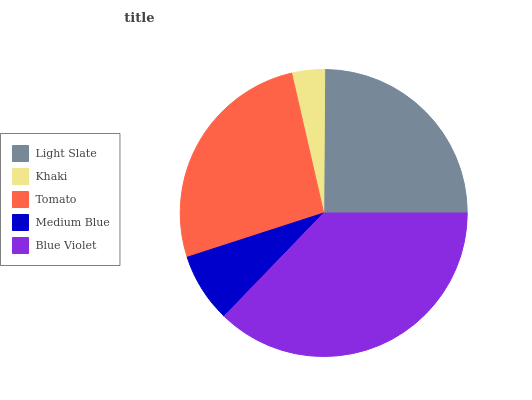Is Khaki the minimum?
Answer yes or no. Yes. Is Blue Violet the maximum?
Answer yes or no. Yes. Is Tomato the minimum?
Answer yes or no. No. Is Tomato the maximum?
Answer yes or no. No. Is Tomato greater than Khaki?
Answer yes or no. Yes. Is Khaki less than Tomato?
Answer yes or no. Yes. Is Khaki greater than Tomato?
Answer yes or no. No. Is Tomato less than Khaki?
Answer yes or no. No. Is Light Slate the high median?
Answer yes or no. Yes. Is Light Slate the low median?
Answer yes or no. Yes. Is Khaki the high median?
Answer yes or no. No. Is Khaki the low median?
Answer yes or no. No. 